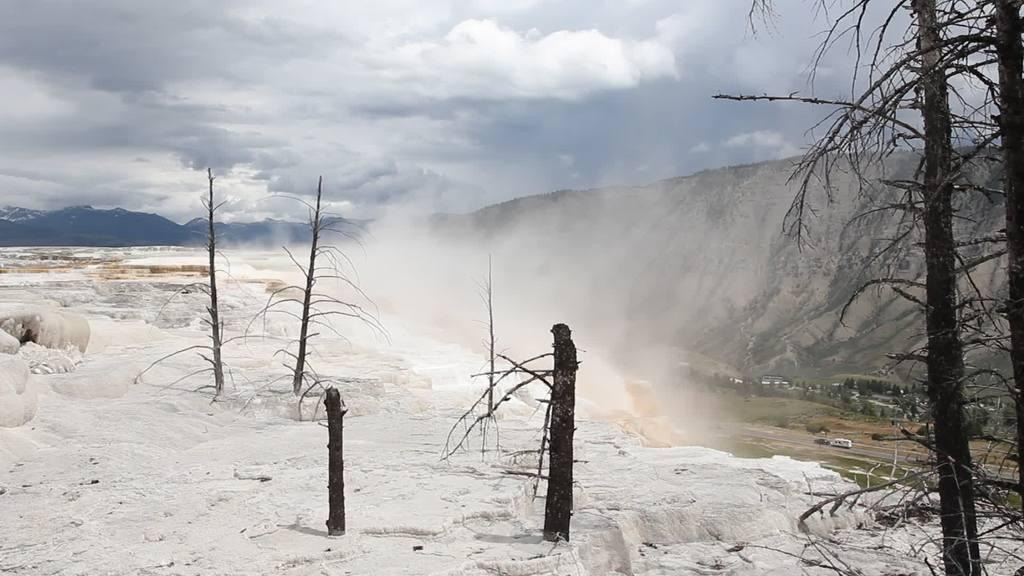What type of weather condition is depicted in the image? There is snow in the image, indicating a cold and wintry scene. What natural elements can be seen in the image? There are trees and hills visible in the image. What man-made object is present in the image? There is a vehicle in the image. What is visible in the sky in the image? There are clouds visible in the image. How many dinosaurs can be seen roaming the hills in the image? There are no dinosaurs present in the image; it depicts a snowy landscape with trees, hills, and a vehicle. What is the size of the giants visible in the image? There are no giants present in the image; it features a snowy landscape with trees, hills, and a vehicle. 